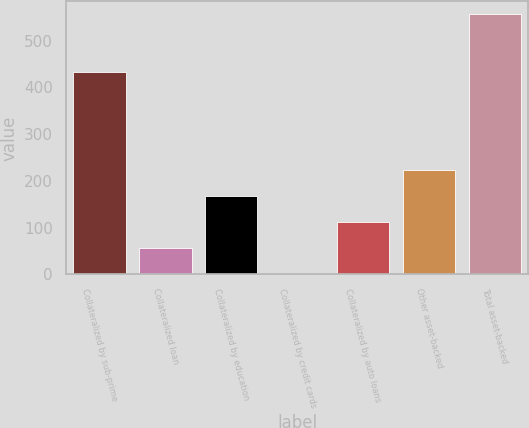Convert chart. <chart><loc_0><loc_0><loc_500><loc_500><bar_chart><fcel>Collateralized by sub-prime<fcel>Collateralized loan<fcel>Collateralized by education<fcel>Collateralized by credit cards<fcel>Collateralized by auto loans<fcel>Other asset-backed<fcel>Total asset-backed<nl><fcel>432<fcel>56.53<fcel>167.53<fcel>1.03<fcel>112.03<fcel>223.03<fcel>556<nl></chart> 